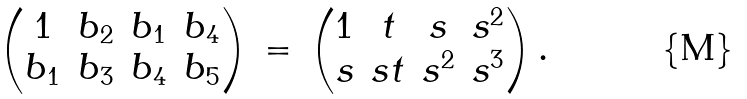Convert formula to latex. <formula><loc_0><loc_0><loc_500><loc_500>\begin{pmatrix} 1 & b _ { 2 } & b _ { 1 } & b _ { 4 } \\ b _ { 1 } & b _ { 3 } & b _ { 4 } & b _ { 5 } \end{pmatrix} \, = \, \begin{pmatrix} 1 & t & s & s ^ { 2 } \\ s & s t & s ^ { 2 } & s ^ { 3 } \end{pmatrix} .</formula> 